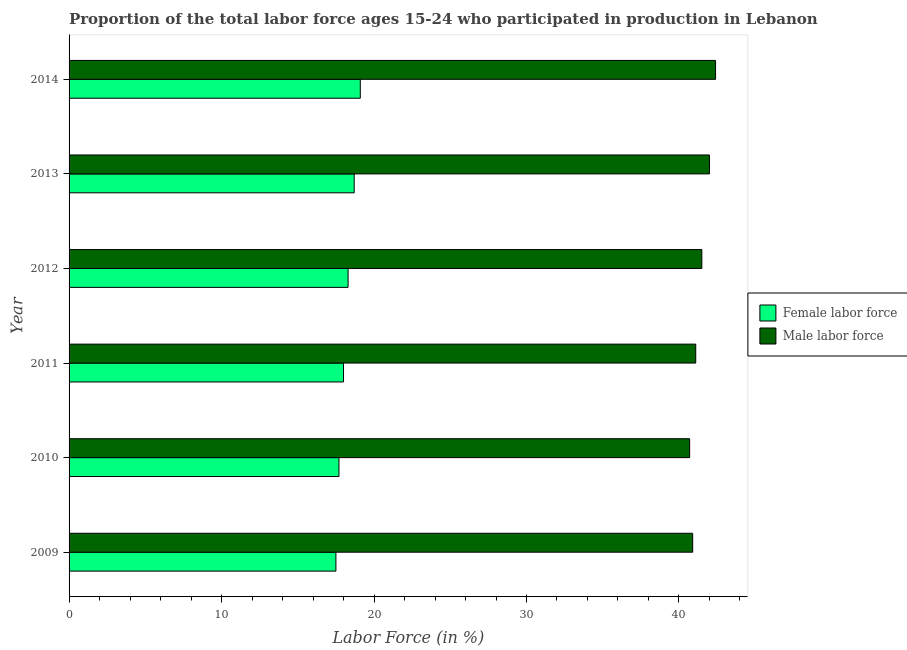How many groups of bars are there?
Provide a short and direct response. 6. What is the label of the 5th group of bars from the top?
Your answer should be compact. 2010. In how many cases, is the number of bars for a given year not equal to the number of legend labels?
Ensure brevity in your answer.  0. Across all years, what is the maximum percentage of female labor force?
Offer a terse response. 19.1. Across all years, what is the minimum percentage of female labor force?
Provide a succinct answer. 17.5. What is the total percentage of female labor force in the graph?
Offer a very short reply. 109.3. What is the difference between the percentage of female labor force in 2009 and the percentage of male labour force in 2013?
Ensure brevity in your answer.  -24.5. What is the average percentage of female labor force per year?
Your answer should be compact. 18.22. In the year 2012, what is the difference between the percentage of male labour force and percentage of female labor force?
Your answer should be very brief. 23.2. In how many years, is the percentage of male labour force greater than 40 %?
Ensure brevity in your answer.  6. What is the ratio of the percentage of male labour force in 2009 to that in 2010?
Provide a succinct answer. 1. Is the percentage of female labor force in 2013 less than that in 2014?
Provide a short and direct response. Yes. Is the difference between the percentage of female labor force in 2011 and 2013 greater than the difference between the percentage of male labour force in 2011 and 2013?
Give a very brief answer. Yes. What is the difference between the highest and the lowest percentage of male labour force?
Ensure brevity in your answer.  1.7. What does the 2nd bar from the top in 2009 represents?
Give a very brief answer. Female labor force. What does the 2nd bar from the bottom in 2009 represents?
Your response must be concise. Male labor force. How many years are there in the graph?
Offer a terse response. 6. Are the values on the major ticks of X-axis written in scientific E-notation?
Keep it short and to the point. No. Where does the legend appear in the graph?
Make the answer very short. Center right. How are the legend labels stacked?
Offer a very short reply. Vertical. What is the title of the graph?
Ensure brevity in your answer.  Proportion of the total labor force ages 15-24 who participated in production in Lebanon. What is the label or title of the X-axis?
Keep it short and to the point. Labor Force (in %). What is the Labor Force (in %) of Female labor force in 2009?
Provide a succinct answer. 17.5. What is the Labor Force (in %) in Male labor force in 2009?
Make the answer very short. 40.9. What is the Labor Force (in %) in Female labor force in 2010?
Your answer should be compact. 17.7. What is the Labor Force (in %) in Male labor force in 2010?
Make the answer very short. 40.7. What is the Labor Force (in %) of Male labor force in 2011?
Make the answer very short. 41.1. What is the Labor Force (in %) of Female labor force in 2012?
Give a very brief answer. 18.3. What is the Labor Force (in %) of Male labor force in 2012?
Ensure brevity in your answer.  41.5. What is the Labor Force (in %) of Female labor force in 2013?
Offer a terse response. 18.7. What is the Labor Force (in %) of Female labor force in 2014?
Your answer should be very brief. 19.1. What is the Labor Force (in %) of Male labor force in 2014?
Offer a terse response. 42.4. Across all years, what is the maximum Labor Force (in %) in Female labor force?
Give a very brief answer. 19.1. Across all years, what is the maximum Labor Force (in %) of Male labor force?
Keep it short and to the point. 42.4. Across all years, what is the minimum Labor Force (in %) of Female labor force?
Give a very brief answer. 17.5. Across all years, what is the minimum Labor Force (in %) in Male labor force?
Provide a short and direct response. 40.7. What is the total Labor Force (in %) of Female labor force in the graph?
Offer a very short reply. 109.3. What is the total Labor Force (in %) in Male labor force in the graph?
Provide a short and direct response. 248.6. What is the difference between the Labor Force (in %) in Male labor force in 2009 and that in 2010?
Offer a very short reply. 0.2. What is the difference between the Labor Force (in %) in Female labor force in 2009 and that in 2011?
Your answer should be very brief. -0.5. What is the difference between the Labor Force (in %) of Female labor force in 2009 and that in 2013?
Keep it short and to the point. -1.2. What is the difference between the Labor Force (in %) of Male labor force in 2009 and that in 2013?
Make the answer very short. -1.1. What is the difference between the Labor Force (in %) of Female labor force in 2009 and that in 2014?
Your answer should be very brief. -1.6. What is the difference between the Labor Force (in %) of Male labor force in 2009 and that in 2014?
Give a very brief answer. -1.5. What is the difference between the Labor Force (in %) in Male labor force in 2010 and that in 2011?
Give a very brief answer. -0.4. What is the difference between the Labor Force (in %) of Female labor force in 2010 and that in 2012?
Your response must be concise. -0.6. What is the difference between the Labor Force (in %) in Male labor force in 2010 and that in 2012?
Offer a terse response. -0.8. What is the difference between the Labor Force (in %) in Male labor force in 2010 and that in 2014?
Keep it short and to the point. -1.7. What is the difference between the Labor Force (in %) of Female labor force in 2011 and that in 2012?
Offer a very short reply. -0.3. What is the difference between the Labor Force (in %) in Male labor force in 2011 and that in 2012?
Your response must be concise. -0.4. What is the difference between the Labor Force (in %) in Male labor force in 2011 and that in 2013?
Give a very brief answer. -0.9. What is the difference between the Labor Force (in %) in Male labor force in 2011 and that in 2014?
Your answer should be very brief. -1.3. What is the difference between the Labor Force (in %) in Male labor force in 2012 and that in 2014?
Provide a short and direct response. -0.9. What is the difference between the Labor Force (in %) in Male labor force in 2013 and that in 2014?
Provide a succinct answer. -0.4. What is the difference between the Labor Force (in %) in Female labor force in 2009 and the Labor Force (in %) in Male labor force in 2010?
Ensure brevity in your answer.  -23.2. What is the difference between the Labor Force (in %) of Female labor force in 2009 and the Labor Force (in %) of Male labor force in 2011?
Your answer should be very brief. -23.6. What is the difference between the Labor Force (in %) in Female labor force in 2009 and the Labor Force (in %) in Male labor force in 2012?
Provide a succinct answer. -24. What is the difference between the Labor Force (in %) of Female labor force in 2009 and the Labor Force (in %) of Male labor force in 2013?
Offer a very short reply. -24.5. What is the difference between the Labor Force (in %) in Female labor force in 2009 and the Labor Force (in %) in Male labor force in 2014?
Your answer should be compact. -24.9. What is the difference between the Labor Force (in %) in Female labor force in 2010 and the Labor Force (in %) in Male labor force in 2011?
Offer a terse response. -23.4. What is the difference between the Labor Force (in %) in Female labor force in 2010 and the Labor Force (in %) in Male labor force in 2012?
Make the answer very short. -23.8. What is the difference between the Labor Force (in %) of Female labor force in 2010 and the Labor Force (in %) of Male labor force in 2013?
Your answer should be very brief. -24.3. What is the difference between the Labor Force (in %) of Female labor force in 2010 and the Labor Force (in %) of Male labor force in 2014?
Offer a very short reply. -24.7. What is the difference between the Labor Force (in %) of Female labor force in 2011 and the Labor Force (in %) of Male labor force in 2012?
Ensure brevity in your answer.  -23.5. What is the difference between the Labor Force (in %) of Female labor force in 2011 and the Labor Force (in %) of Male labor force in 2013?
Provide a short and direct response. -24. What is the difference between the Labor Force (in %) of Female labor force in 2011 and the Labor Force (in %) of Male labor force in 2014?
Offer a very short reply. -24.4. What is the difference between the Labor Force (in %) of Female labor force in 2012 and the Labor Force (in %) of Male labor force in 2013?
Make the answer very short. -23.7. What is the difference between the Labor Force (in %) of Female labor force in 2012 and the Labor Force (in %) of Male labor force in 2014?
Give a very brief answer. -24.1. What is the difference between the Labor Force (in %) of Female labor force in 2013 and the Labor Force (in %) of Male labor force in 2014?
Provide a succinct answer. -23.7. What is the average Labor Force (in %) in Female labor force per year?
Make the answer very short. 18.22. What is the average Labor Force (in %) of Male labor force per year?
Your response must be concise. 41.43. In the year 2009, what is the difference between the Labor Force (in %) in Female labor force and Labor Force (in %) in Male labor force?
Ensure brevity in your answer.  -23.4. In the year 2010, what is the difference between the Labor Force (in %) of Female labor force and Labor Force (in %) of Male labor force?
Keep it short and to the point. -23. In the year 2011, what is the difference between the Labor Force (in %) in Female labor force and Labor Force (in %) in Male labor force?
Ensure brevity in your answer.  -23.1. In the year 2012, what is the difference between the Labor Force (in %) of Female labor force and Labor Force (in %) of Male labor force?
Offer a very short reply. -23.2. In the year 2013, what is the difference between the Labor Force (in %) of Female labor force and Labor Force (in %) of Male labor force?
Ensure brevity in your answer.  -23.3. In the year 2014, what is the difference between the Labor Force (in %) in Female labor force and Labor Force (in %) in Male labor force?
Provide a succinct answer. -23.3. What is the ratio of the Labor Force (in %) in Female labor force in 2009 to that in 2010?
Keep it short and to the point. 0.99. What is the ratio of the Labor Force (in %) in Male labor force in 2009 to that in 2010?
Ensure brevity in your answer.  1. What is the ratio of the Labor Force (in %) of Female labor force in 2009 to that in 2011?
Your answer should be very brief. 0.97. What is the ratio of the Labor Force (in %) in Male labor force in 2009 to that in 2011?
Offer a very short reply. 1. What is the ratio of the Labor Force (in %) of Female labor force in 2009 to that in 2012?
Offer a terse response. 0.96. What is the ratio of the Labor Force (in %) in Male labor force in 2009 to that in 2012?
Your answer should be compact. 0.99. What is the ratio of the Labor Force (in %) in Female labor force in 2009 to that in 2013?
Ensure brevity in your answer.  0.94. What is the ratio of the Labor Force (in %) in Male labor force in 2009 to that in 2013?
Your response must be concise. 0.97. What is the ratio of the Labor Force (in %) in Female labor force in 2009 to that in 2014?
Make the answer very short. 0.92. What is the ratio of the Labor Force (in %) in Male labor force in 2009 to that in 2014?
Offer a very short reply. 0.96. What is the ratio of the Labor Force (in %) in Female labor force in 2010 to that in 2011?
Give a very brief answer. 0.98. What is the ratio of the Labor Force (in %) of Male labor force in 2010 to that in 2011?
Ensure brevity in your answer.  0.99. What is the ratio of the Labor Force (in %) in Female labor force in 2010 to that in 2012?
Your answer should be very brief. 0.97. What is the ratio of the Labor Force (in %) of Male labor force in 2010 to that in 2012?
Keep it short and to the point. 0.98. What is the ratio of the Labor Force (in %) of Female labor force in 2010 to that in 2013?
Ensure brevity in your answer.  0.95. What is the ratio of the Labor Force (in %) of Male labor force in 2010 to that in 2013?
Your response must be concise. 0.97. What is the ratio of the Labor Force (in %) of Female labor force in 2010 to that in 2014?
Offer a terse response. 0.93. What is the ratio of the Labor Force (in %) in Male labor force in 2010 to that in 2014?
Provide a short and direct response. 0.96. What is the ratio of the Labor Force (in %) of Female labor force in 2011 to that in 2012?
Give a very brief answer. 0.98. What is the ratio of the Labor Force (in %) in Female labor force in 2011 to that in 2013?
Offer a very short reply. 0.96. What is the ratio of the Labor Force (in %) in Male labor force in 2011 to that in 2013?
Ensure brevity in your answer.  0.98. What is the ratio of the Labor Force (in %) in Female labor force in 2011 to that in 2014?
Make the answer very short. 0.94. What is the ratio of the Labor Force (in %) in Male labor force in 2011 to that in 2014?
Your answer should be compact. 0.97. What is the ratio of the Labor Force (in %) of Female labor force in 2012 to that in 2013?
Offer a terse response. 0.98. What is the ratio of the Labor Force (in %) of Female labor force in 2012 to that in 2014?
Your answer should be very brief. 0.96. What is the ratio of the Labor Force (in %) of Male labor force in 2012 to that in 2014?
Make the answer very short. 0.98. What is the ratio of the Labor Force (in %) of Female labor force in 2013 to that in 2014?
Provide a short and direct response. 0.98. What is the ratio of the Labor Force (in %) of Male labor force in 2013 to that in 2014?
Your answer should be compact. 0.99. What is the difference between the highest and the second highest Labor Force (in %) in Female labor force?
Your response must be concise. 0.4. What is the difference between the highest and the second highest Labor Force (in %) of Male labor force?
Offer a very short reply. 0.4. What is the difference between the highest and the lowest Labor Force (in %) of Male labor force?
Offer a very short reply. 1.7. 